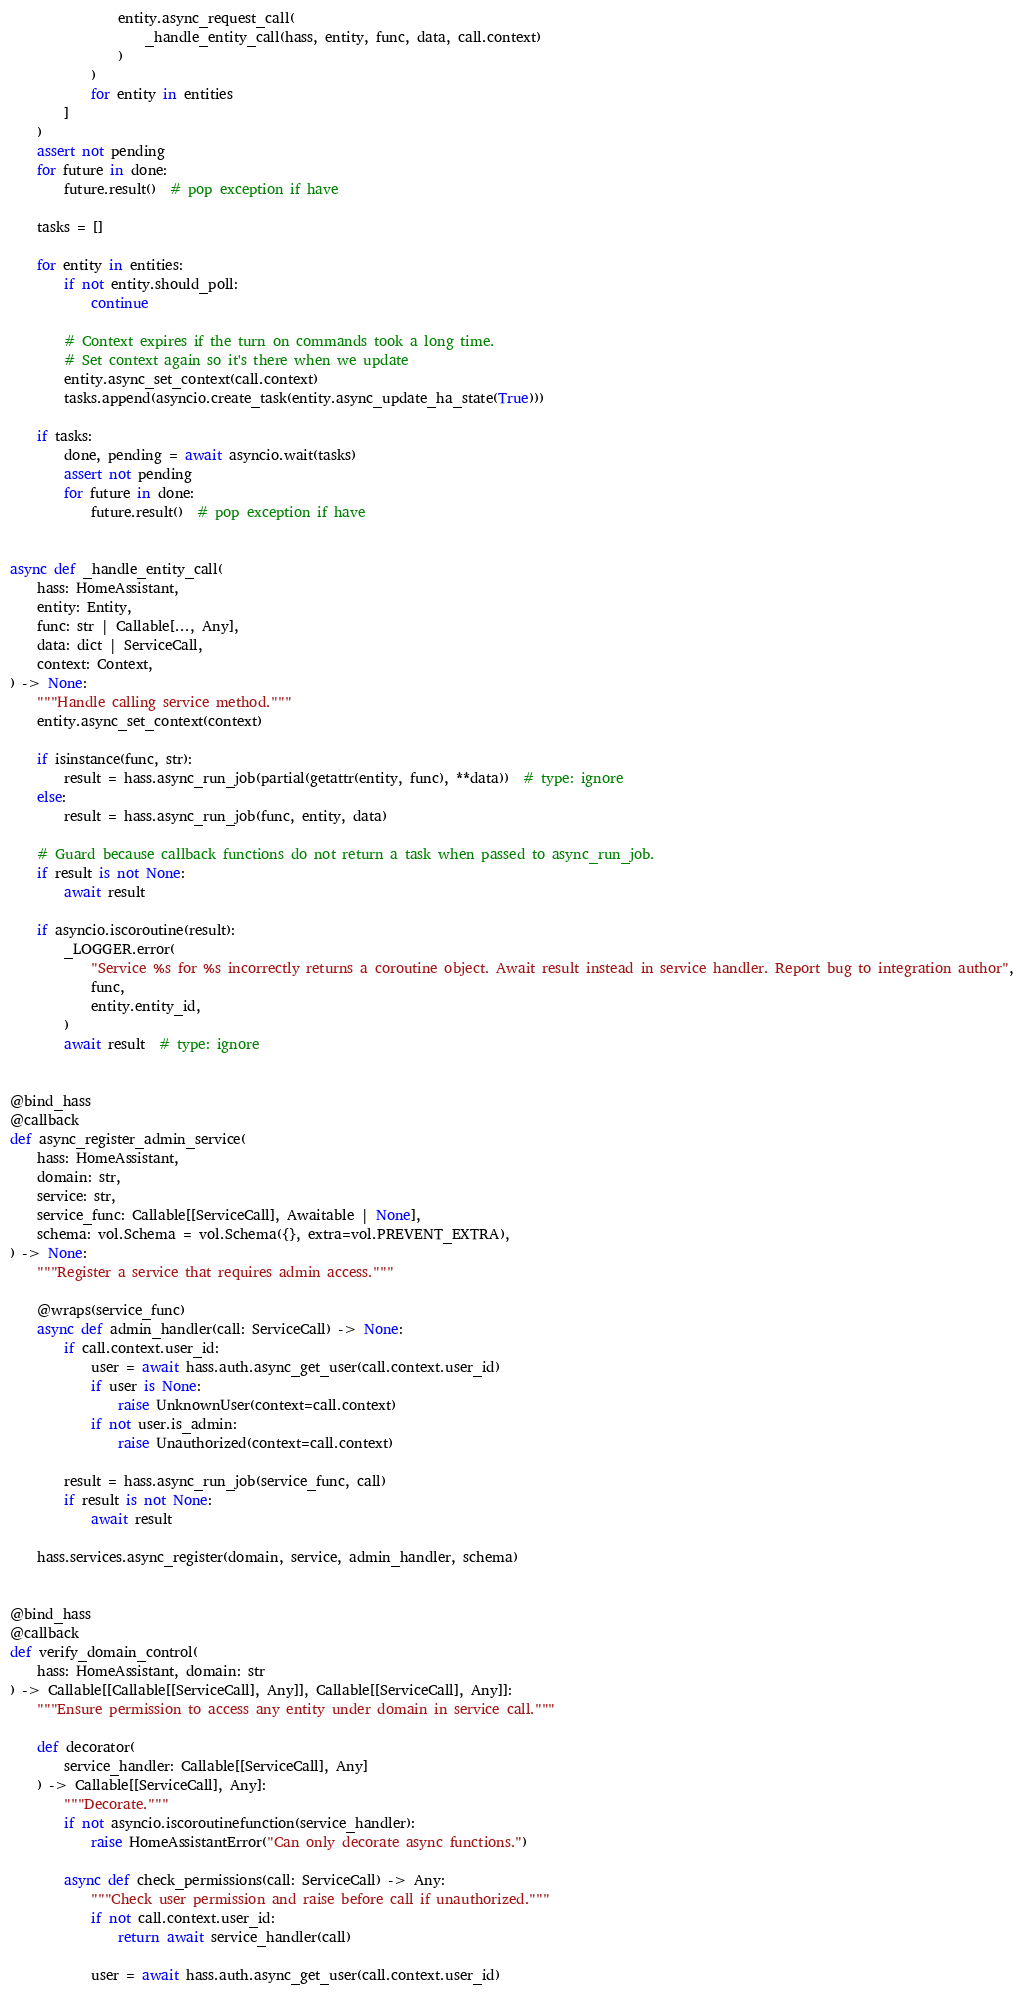Convert code to text. <code><loc_0><loc_0><loc_500><loc_500><_Python_>                entity.async_request_call(
                    _handle_entity_call(hass, entity, func, data, call.context)
                )
            )
            for entity in entities
        ]
    )
    assert not pending
    for future in done:
        future.result()  # pop exception if have

    tasks = []

    for entity in entities:
        if not entity.should_poll:
            continue

        # Context expires if the turn on commands took a long time.
        # Set context again so it's there when we update
        entity.async_set_context(call.context)
        tasks.append(asyncio.create_task(entity.async_update_ha_state(True)))

    if tasks:
        done, pending = await asyncio.wait(tasks)
        assert not pending
        for future in done:
            future.result()  # pop exception if have


async def _handle_entity_call(
    hass: HomeAssistant,
    entity: Entity,
    func: str | Callable[..., Any],
    data: dict | ServiceCall,
    context: Context,
) -> None:
    """Handle calling service method."""
    entity.async_set_context(context)

    if isinstance(func, str):
        result = hass.async_run_job(partial(getattr(entity, func), **data))  # type: ignore
    else:
        result = hass.async_run_job(func, entity, data)

    # Guard because callback functions do not return a task when passed to async_run_job.
    if result is not None:
        await result

    if asyncio.iscoroutine(result):
        _LOGGER.error(
            "Service %s for %s incorrectly returns a coroutine object. Await result instead in service handler. Report bug to integration author",
            func,
            entity.entity_id,
        )
        await result  # type: ignore


@bind_hass
@callback
def async_register_admin_service(
    hass: HomeAssistant,
    domain: str,
    service: str,
    service_func: Callable[[ServiceCall], Awaitable | None],
    schema: vol.Schema = vol.Schema({}, extra=vol.PREVENT_EXTRA),
) -> None:
    """Register a service that requires admin access."""

    @wraps(service_func)
    async def admin_handler(call: ServiceCall) -> None:
        if call.context.user_id:
            user = await hass.auth.async_get_user(call.context.user_id)
            if user is None:
                raise UnknownUser(context=call.context)
            if not user.is_admin:
                raise Unauthorized(context=call.context)

        result = hass.async_run_job(service_func, call)
        if result is not None:
            await result

    hass.services.async_register(domain, service, admin_handler, schema)


@bind_hass
@callback
def verify_domain_control(
    hass: HomeAssistant, domain: str
) -> Callable[[Callable[[ServiceCall], Any]], Callable[[ServiceCall], Any]]:
    """Ensure permission to access any entity under domain in service call."""

    def decorator(
        service_handler: Callable[[ServiceCall], Any]
    ) -> Callable[[ServiceCall], Any]:
        """Decorate."""
        if not asyncio.iscoroutinefunction(service_handler):
            raise HomeAssistantError("Can only decorate async functions.")

        async def check_permissions(call: ServiceCall) -> Any:
            """Check user permission and raise before call if unauthorized."""
            if not call.context.user_id:
                return await service_handler(call)

            user = await hass.auth.async_get_user(call.context.user_id)
</code> 